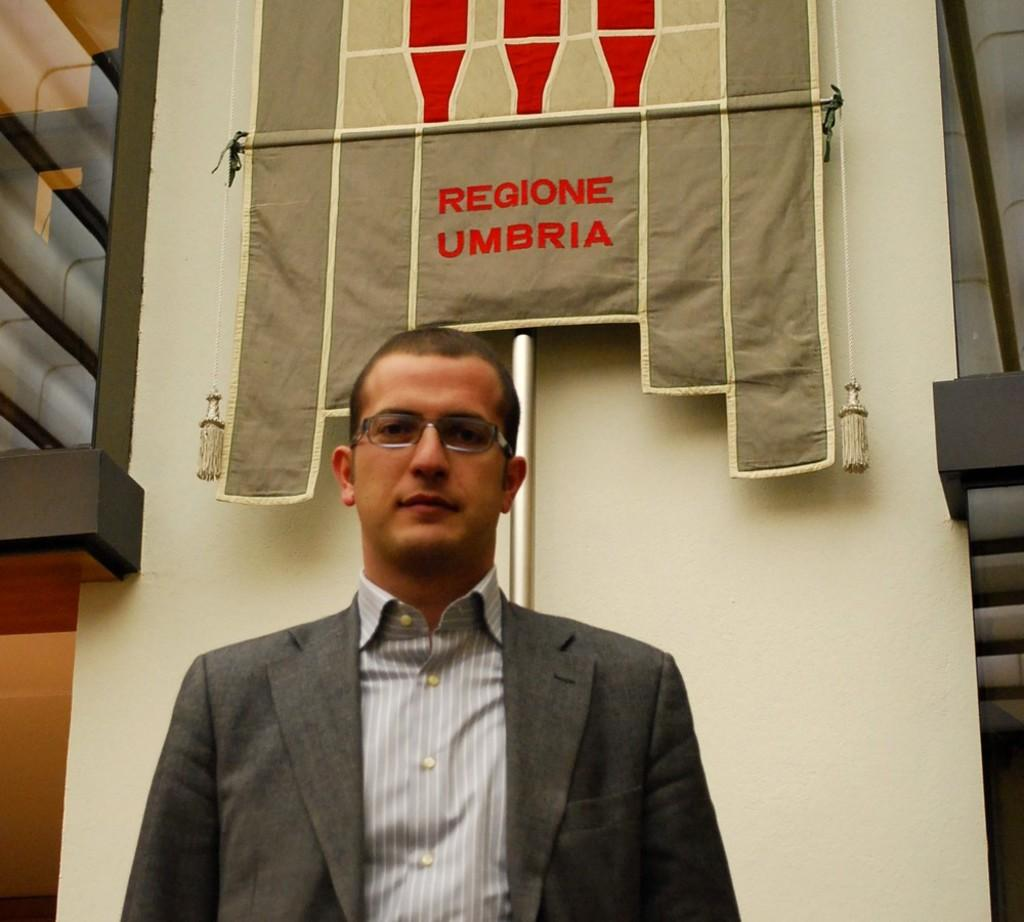What is the main subject of the image? There is a person standing in the image. Where is the person standing? The person is standing on the floor. What else can be seen in the image besides the person? There is a banner in the image. Can you describe the location of the banner? The banner is in front of a wall. What type of cracker is being used to hold up the banner in the image? There is no cracker present in the image, nor is there any indication that the banner is being held up by a cracker. 